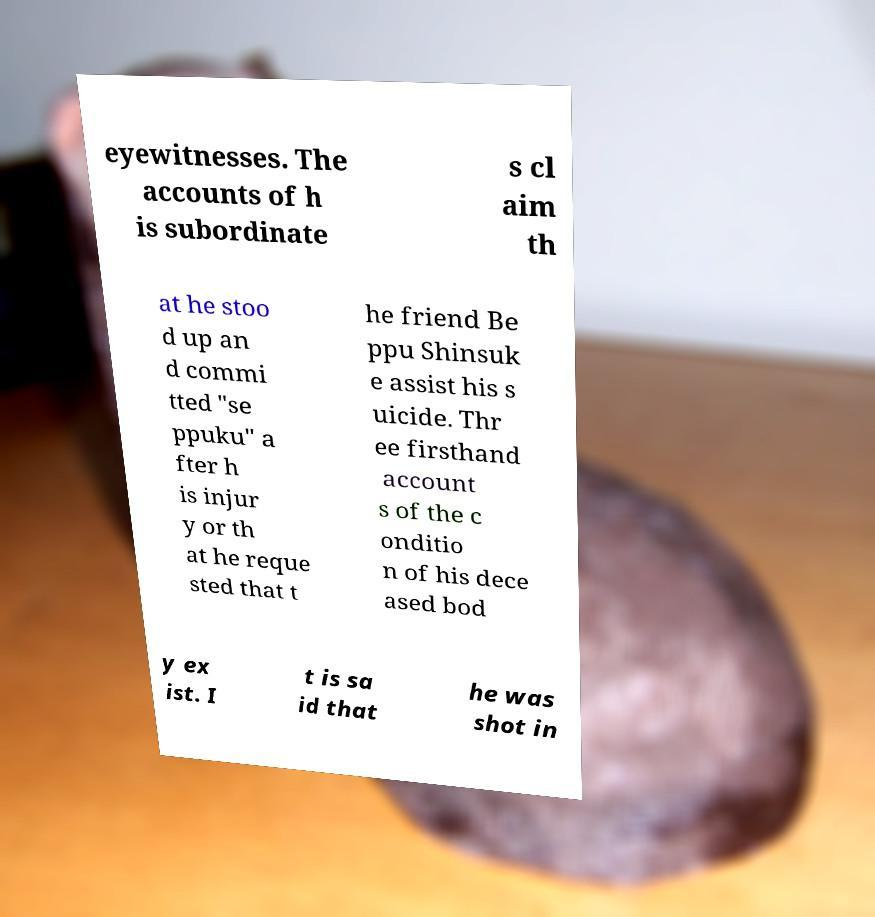What messages or text are displayed in this image? I need them in a readable, typed format. eyewitnesses. The accounts of h is subordinate s cl aim th at he stoo d up an d commi tted "se ppuku" a fter h is injur y or th at he reque sted that t he friend Be ppu Shinsuk e assist his s uicide. Thr ee firsthand account s of the c onditio n of his dece ased bod y ex ist. I t is sa id that he was shot in 